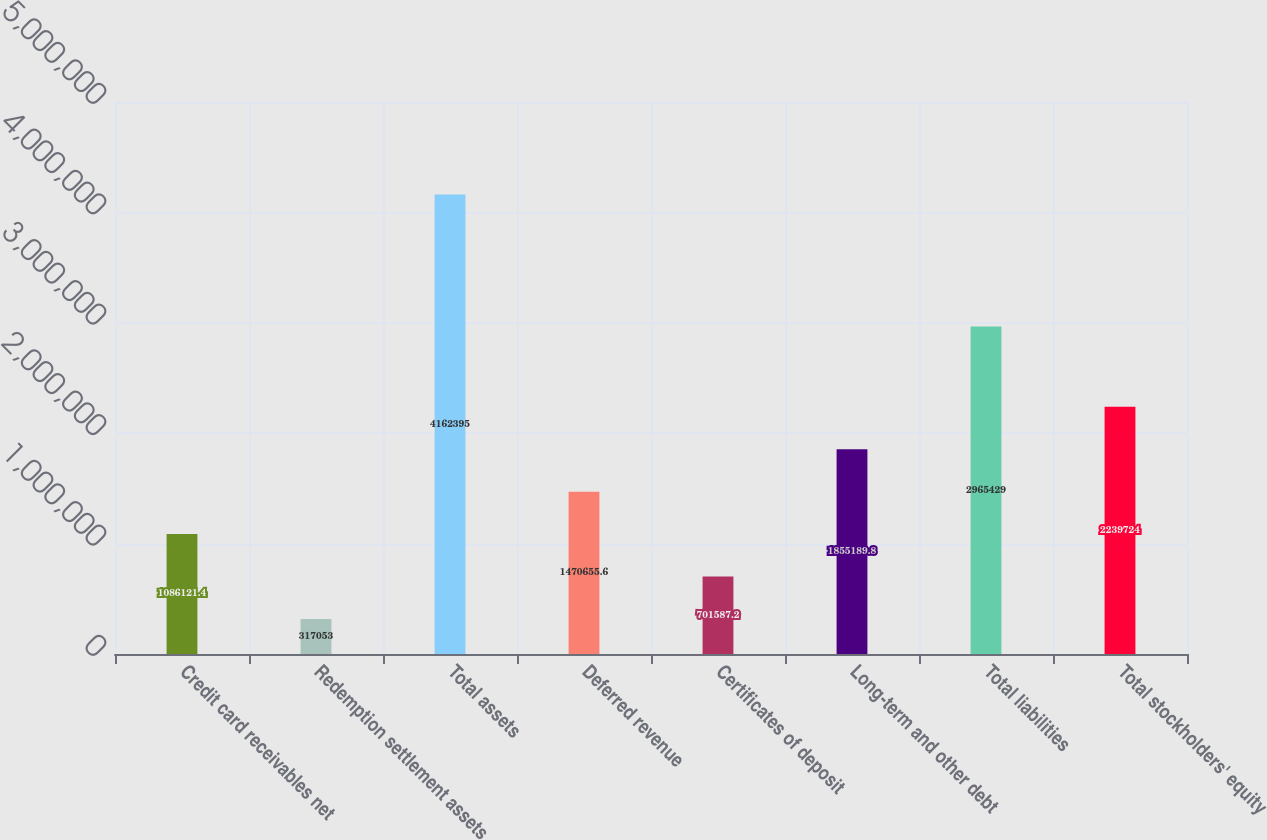Convert chart. <chart><loc_0><loc_0><loc_500><loc_500><bar_chart><fcel>Credit card receivables net<fcel>Redemption settlement assets<fcel>Total assets<fcel>Deferred revenue<fcel>Certificates of deposit<fcel>Long-term and other debt<fcel>Total liabilities<fcel>Total stockholders' equity<nl><fcel>1.08612e+06<fcel>317053<fcel>4.1624e+06<fcel>1.47066e+06<fcel>701587<fcel>1.85519e+06<fcel>2.96543e+06<fcel>2.23972e+06<nl></chart> 